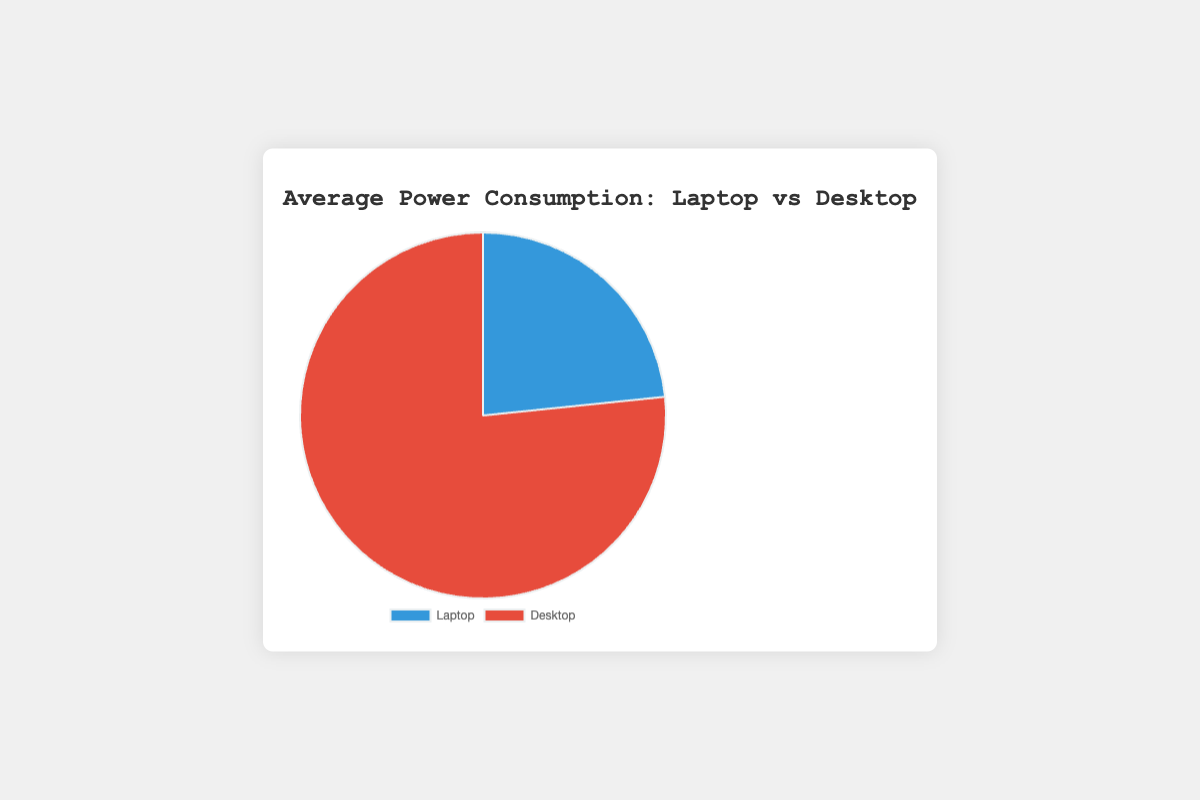Compare the average power consumption of laptops and desktops. By observing the pie chart, the average power consumption for each device is displayed. The desktop has a higher average power consumption compared to the laptop.
Answer: Desktop What colors represent laptop and desktop on the pie chart? The pie chart uses two distinct colors for different devices. The laptop is represented by the color blue, and the desktop is represented by the color red.
Answer: Blue and Red Which device consumes more power on average? From the pie chart, it is indicated that the average power consumption for desktops is greater than that for laptops.
Answer: Desktop By how much does the average desktop power consumption exceed the laptop's? According to the chart, the average power consumption of laptops is 47.5 W and that of desktops is 155.75 W. The difference is 155.75 W - 47.5 W = 108.25 W.
Answer: 108.25 W What is the average power consumption of laptops? The pie chart provides average values for each device. The average power consumption of laptops is shown as 47.5 W.
Answer: 47.5 W Calculate the total power consumption for laptops during all study sessions. To find the total power consumption for laptops, sum the values for all sessions: 45 + 50 + 47 + 48 = 190 W.
Answer: 190 W What percentage of the total power consumption is attributed to desktops? The average power consumption for laptops and desktops is 47.5 W and 155.75 W, respectively. The sum of these averages is 203.25 W. The percentage for desktops is (155.75 / 203.25) * 100 = approximately 76.63%.
Answer: Approximately 76.63% Which session had the highest power consumption for laptops? By checking the dataset, it shows that the second session had the highest power consumption for laptops at 50 W.
Answer: Session 2 Compare the average power consumption difference between laptops and desktops in percentages. The average power consumption for laptops is 47.5 W and for desktops is 155.75 W. The difference is 155.75 - 47.5 = 108.25 W. The percentage difference relative to laptop's average consumption is (108.25 / 47.5) * 100 = approximately 227.37%.
Answer: Approximately 227.37% If you combine the power consumption of both devices during one session, what is the average total power consumption per session? Adding the average values per session from both devices gives: (45 + 150 + 50 + 160 + 47 + 155 + 48 + 158) / 4 = 345 W per session.
Answer: 345 W per session 